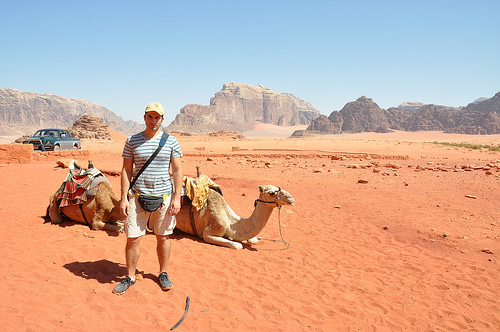<image>
Is the man behind the camel? No. The man is not behind the camel. From this viewpoint, the man appears to be positioned elsewhere in the scene. Is the man to the right of the car? Yes. From this viewpoint, the man is positioned to the right side relative to the car. Is there a man next to the sand? No. The man is not positioned next to the sand. They are located in different areas of the scene. 